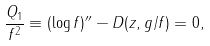<formula> <loc_0><loc_0><loc_500><loc_500>\frac { Q _ { 1 } } { f ^ { 2 } } \equiv ( \log f ) ^ { \prime \prime } - D ( z , g / f ) = 0 ,</formula> 